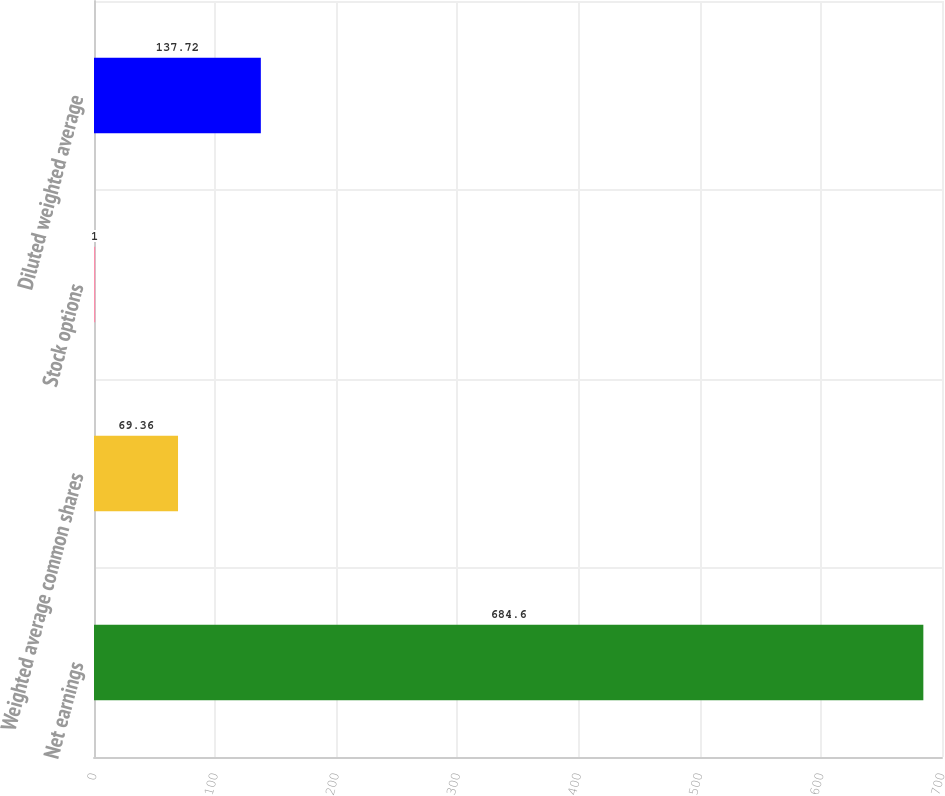Convert chart to OTSL. <chart><loc_0><loc_0><loc_500><loc_500><bar_chart><fcel>Net earnings<fcel>Weighted average common shares<fcel>Stock options<fcel>Diluted weighted average<nl><fcel>684.6<fcel>69.36<fcel>1<fcel>137.72<nl></chart> 